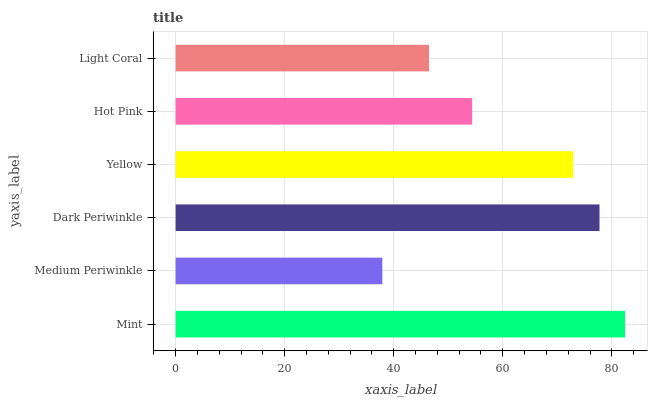Is Medium Periwinkle the minimum?
Answer yes or no. Yes. Is Mint the maximum?
Answer yes or no. Yes. Is Dark Periwinkle the minimum?
Answer yes or no. No. Is Dark Periwinkle the maximum?
Answer yes or no. No. Is Dark Periwinkle greater than Medium Periwinkle?
Answer yes or no. Yes. Is Medium Periwinkle less than Dark Periwinkle?
Answer yes or no. Yes. Is Medium Periwinkle greater than Dark Periwinkle?
Answer yes or no. No. Is Dark Periwinkle less than Medium Periwinkle?
Answer yes or no. No. Is Yellow the high median?
Answer yes or no. Yes. Is Hot Pink the low median?
Answer yes or no. Yes. Is Medium Periwinkle the high median?
Answer yes or no. No. Is Yellow the low median?
Answer yes or no. No. 